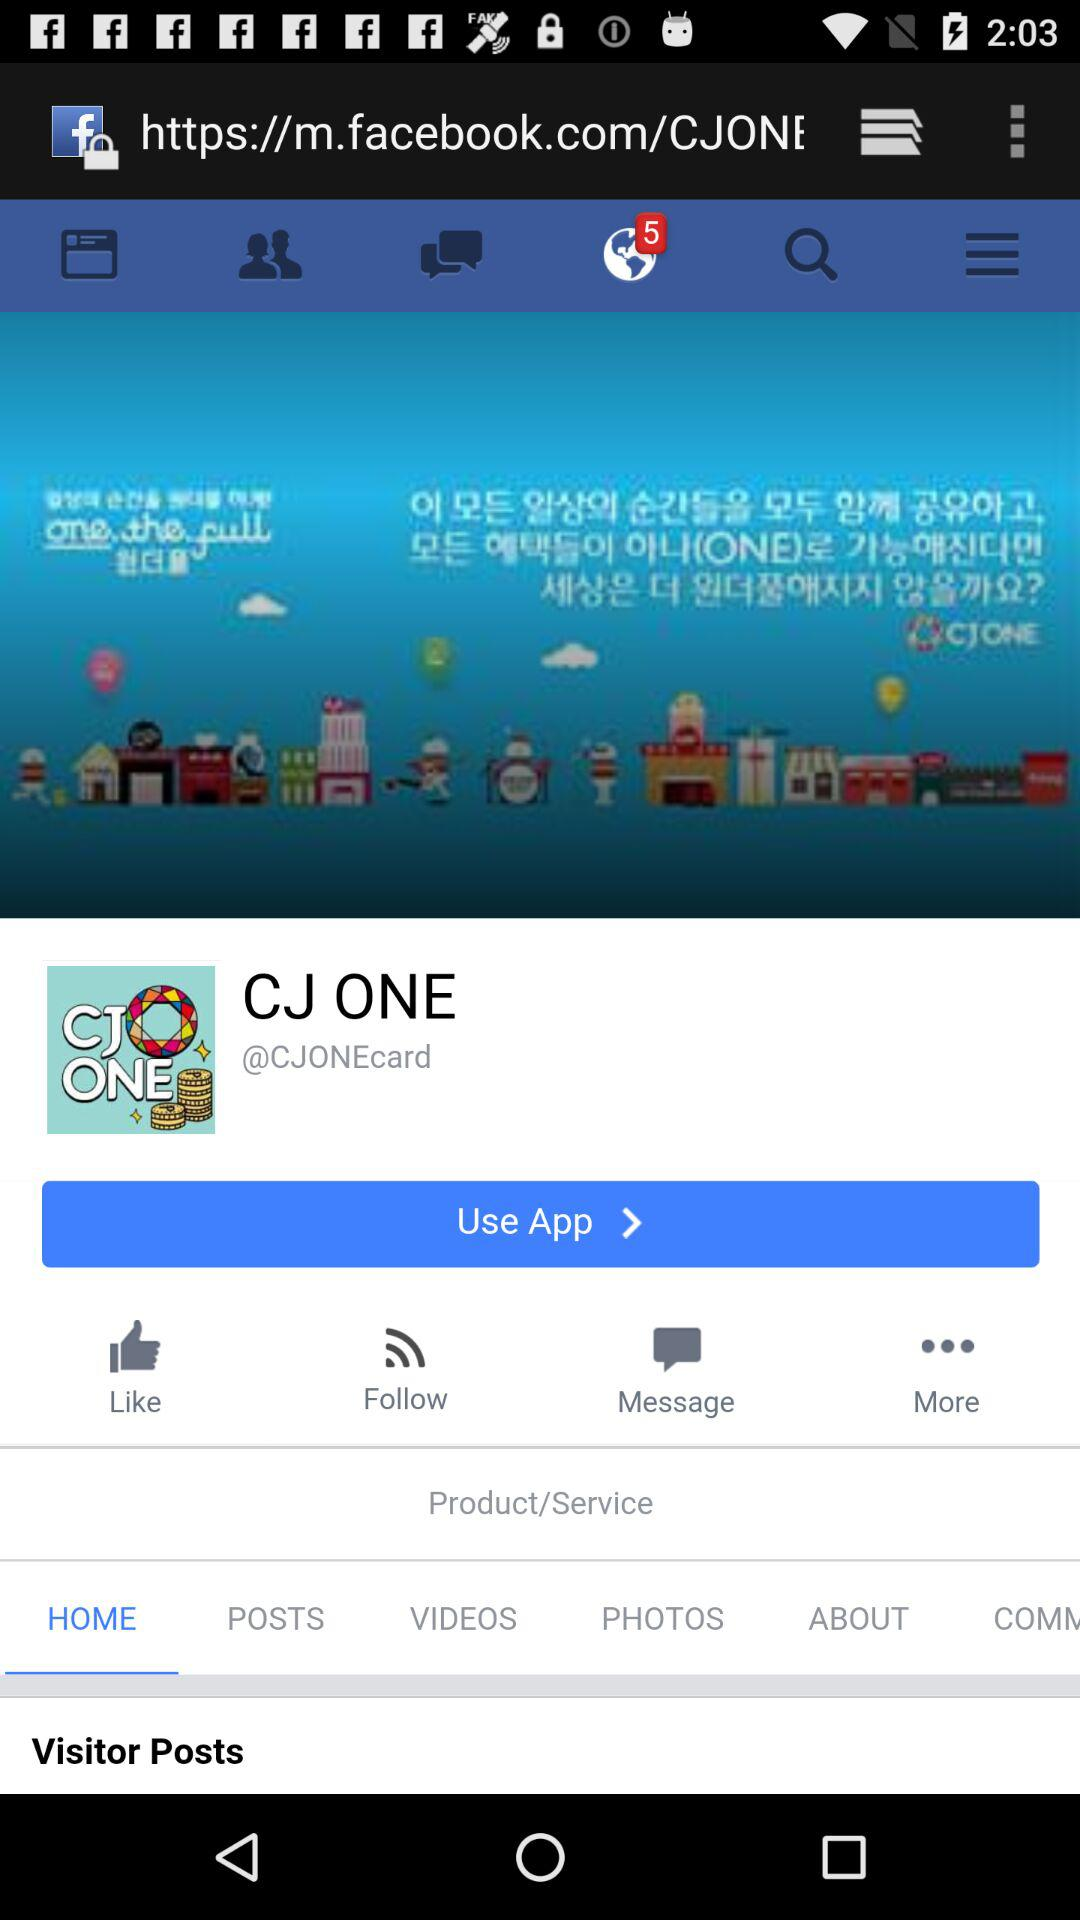Which tab is selected? The selected tabs are "Notifications" and "HOME". 